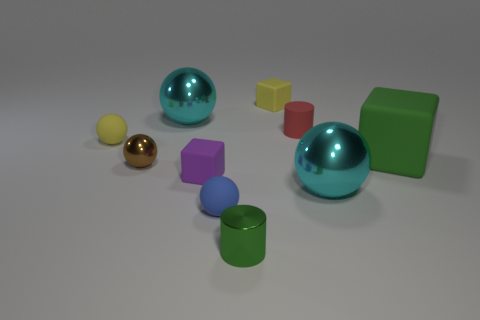Subtract all tiny brown balls. How many balls are left? 4 Subtract all cylinders. How many objects are left? 8 Subtract all big things. Subtract all rubber cylinders. How many objects are left? 6 Add 8 large green blocks. How many large green blocks are left? 9 Add 6 tiny metallic things. How many tiny metallic things exist? 8 Subtract 0 brown cubes. How many objects are left? 10 